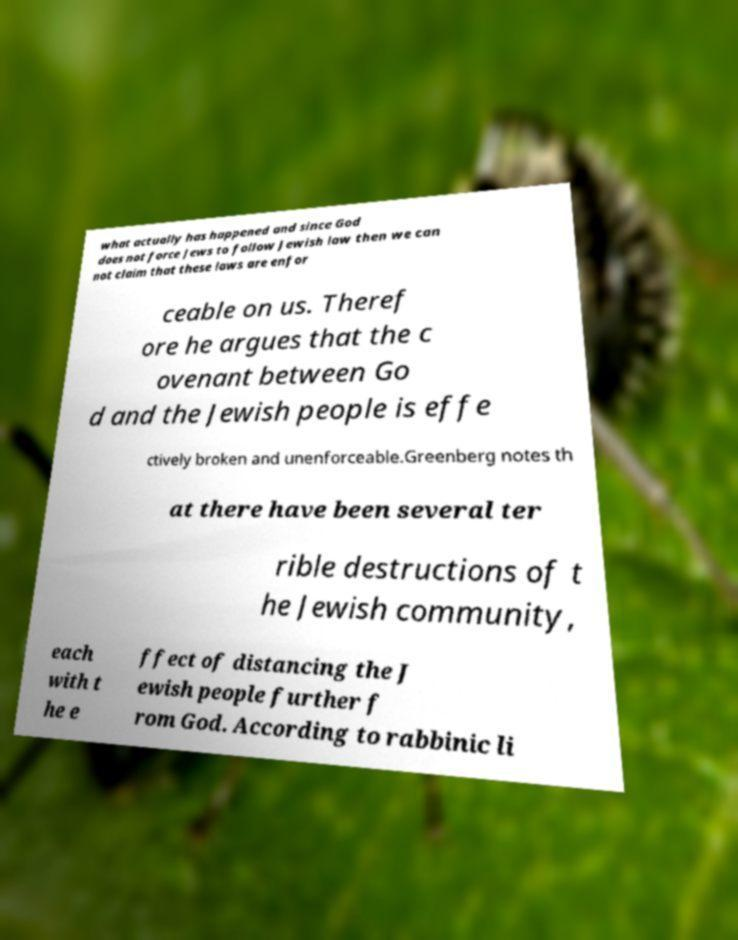Please read and relay the text visible in this image. What does it say? what actually has happened and since God does not force Jews to follow Jewish law then we can not claim that these laws are enfor ceable on us. Theref ore he argues that the c ovenant between Go d and the Jewish people is effe ctively broken and unenforceable.Greenberg notes th at there have been several ter rible destructions of t he Jewish community, each with t he e ffect of distancing the J ewish people further f rom God. According to rabbinic li 